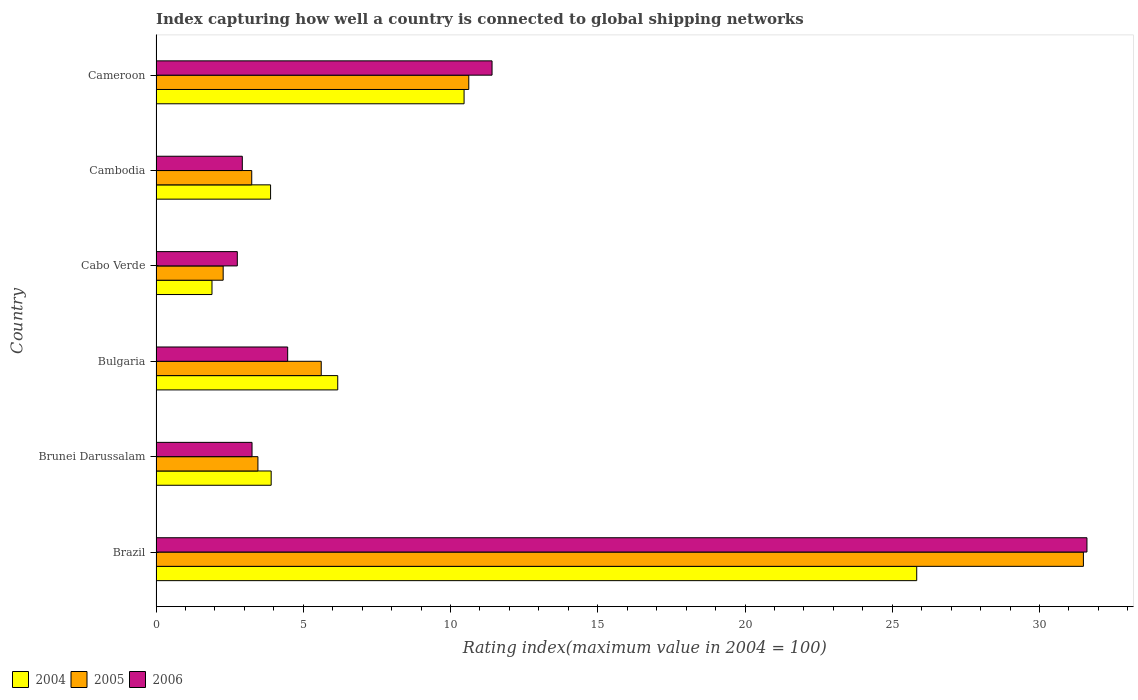How many different coloured bars are there?
Your answer should be compact. 3. How many groups of bars are there?
Your answer should be compact. 6. Are the number of bars per tick equal to the number of legend labels?
Your answer should be compact. Yes. Are the number of bars on each tick of the Y-axis equal?
Ensure brevity in your answer.  Yes. How many bars are there on the 3rd tick from the top?
Your answer should be compact. 3. What is the label of the 4th group of bars from the top?
Give a very brief answer. Bulgaria. What is the rating index in 2005 in Brazil?
Ensure brevity in your answer.  31.49. Across all countries, what is the maximum rating index in 2006?
Your answer should be compact. 31.61. Across all countries, what is the minimum rating index in 2005?
Your answer should be very brief. 2.28. In which country was the rating index in 2006 maximum?
Offer a very short reply. Brazil. In which country was the rating index in 2006 minimum?
Make the answer very short. Cabo Verde. What is the total rating index in 2004 in the graph?
Offer a very short reply. 52.16. What is the difference between the rating index in 2005 in Brunei Darussalam and that in Cabo Verde?
Offer a very short reply. 1.18. What is the difference between the rating index in 2006 in Cambodia and the rating index in 2005 in Bulgaria?
Ensure brevity in your answer.  -2.68. What is the average rating index in 2006 per country?
Keep it short and to the point. 9.41. What is the difference between the rating index in 2005 and rating index in 2004 in Cameroon?
Your response must be concise. 0.16. What is the ratio of the rating index in 2006 in Brazil to that in Bulgaria?
Your answer should be compact. 7.07. Is the rating index in 2005 in Brunei Darussalam less than that in Cambodia?
Keep it short and to the point. No. Is the difference between the rating index in 2005 in Brazil and Bulgaria greater than the difference between the rating index in 2004 in Brazil and Bulgaria?
Offer a very short reply. Yes. What is the difference between the highest and the second highest rating index in 2006?
Offer a terse response. 20.2. What is the difference between the highest and the lowest rating index in 2004?
Provide a succinct answer. 23.93. Is the sum of the rating index in 2005 in Bulgaria and Cameroon greater than the maximum rating index in 2006 across all countries?
Ensure brevity in your answer.  No. What does the 2nd bar from the bottom in Bulgaria represents?
Offer a terse response. 2005. Is it the case that in every country, the sum of the rating index in 2006 and rating index in 2004 is greater than the rating index in 2005?
Provide a short and direct response. Yes. Are all the bars in the graph horizontal?
Keep it short and to the point. Yes. Does the graph contain any zero values?
Offer a terse response. No. Does the graph contain grids?
Offer a terse response. No. Where does the legend appear in the graph?
Ensure brevity in your answer.  Bottom left. How many legend labels are there?
Make the answer very short. 3. How are the legend labels stacked?
Offer a terse response. Horizontal. What is the title of the graph?
Keep it short and to the point. Index capturing how well a country is connected to global shipping networks. What is the label or title of the X-axis?
Keep it short and to the point. Rating index(maximum value in 2004 = 100). What is the label or title of the Y-axis?
Keep it short and to the point. Country. What is the Rating index(maximum value in 2004 = 100) in 2004 in Brazil?
Your answer should be very brief. 25.83. What is the Rating index(maximum value in 2004 = 100) of 2005 in Brazil?
Provide a short and direct response. 31.49. What is the Rating index(maximum value in 2004 = 100) of 2006 in Brazil?
Make the answer very short. 31.61. What is the Rating index(maximum value in 2004 = 100) in 2004 in Brunei Darussalam?
Give a very brief answer. 3.91. What is the Rating index(maximum value in 2004 = 100) of 2005 in Brunei Darussalam?
Keep it short and to the point. 3.46. What is the Rating index(maximum value in 2004 = 100) of 2006 in Brunei Darussalam?
Your answer should be very brief. 3.26. What is the Rating index(maximum value in 2004 = 100) in 2004 in Bulgaria?
Your answer should be very brief. 6.17. What is the Rating index(maximum value in 2004 = 100) of 2005 in Bulgaria?
Ensure brevity in your answer.  5.61. What is the Rating index(maximum value in 2004 = 100) in 2006 in Bulgaria?
Your answer should be compact. 4.47. What is the Rating index(maximum value in 2004 = 100) in 2005 in Cabo Verde?
Provide a succinct answer. 2.28. What is the Rating index(maximum value in 2004 = 100) in 2006 in Cabo Verde?
Your answer should be compact. 2.76. What is the Rating index(maximum value in 2004 = 100) in 2004 in Cambodia?
Ensure brevity in your answer.  3.89. What is the Rating index(maximum value in 2004 = 100) in 2006 in Cambodia?
Keep it short and to the point. 2.93. What is the Rating index(maximum value in 2004 = 100) in 2004 in Cameroon?
Provide a short and direct response. 10.46. What is the Rating index(maximum value in 2004 = 100) in 2005 in Cameroon?
Make the answer very short. 10.62. What is the Rating index(maximum value in 2004 = 100) of 2006 in Cameroon?
Offer a terse response. 11.41. Across all countries, what is the maximum Rating index(maximum value in 2004 = 100) in 2004?
Keep it short and to the point. 25.83. Across all countries, what is the maximum Rating index(maximum value in 2004 = 100) of 2005?
Make the answer very short. 31.49. Across all countries, what is the maximum Rating index(maximum value in 2004 = 100) of 2006?
Give a very brief answer. 31.61. Across all countries, what is the minimum Rating index(maximum value in 2004 = 100) in 2005?
Provide a short and direct response. 2.28. Across all countries, what is the minimum Rating index(maximum value in 2004 = 100) of 2006?
Keep it short and to the point. 2.76. What is the total Rating index(maximum value in 2004 = 100) in 2004 in the graph?
Offer a very short reply. 52.16. What is the total Rating index(maximum value in 2004 = 100) of 2005 in the graph?
Ensure brevity in your answer.  56.71. What is the total Rating index(maximum value in 2004 = 100) of 2006 in the graph?
Your answer should be very brief. 56.44. What is the difference between the Rating index(maximum value in 2004 = 100) in 2004 in Brazil and that in Brunei Darussalam?
Your answer should be compact. 21.92. What is the difference between the Rating index(maximum value in 2004 = 100) of 2005 in Brazil and that in Brunei Darussalam?
Provide a short and direct response. 28.03. What is the difference between the Rating index(maximum value in 2004 = 100) in 2006 in Brazil and that in Brunei Darussalam?
Keep it short and to the point. 28.35. What is the difference between the Rating index(maximum value in 2004 = 100) of 2004 in Brazil and that in Bulgaria?
Offer a terse response. 19.66. What is the difference between the Rating index(maximum value in 2004 = 100) of 2005 in Brazil and that in Bulgaria?
Provide a short and direct response. 25.88. What is the difference between the Rating index(maximum value in 2004 = 100) in 2006 in Brazil and that in Bulgaria?
Offer a very short reply. 27.14. What is the difference between the Rating index(maximum value in 2004 = 100) in 2004 in Brazil and that in Cabo Verde?
Your response must be concise. 23.93. What is the difference between the Rating index(maximum value in 2004 = 100) in 2005 in Brazil and that in Cabo Verde?
Offer a terse response. 29.21. What is the difference between the Rating index(maximum value in 2004 = 100) of 2006 in Brazil and that in Cabo Verde?
Your answer should be very brief. 28.85. What is the difference between the Rating index(maximum value in 2004 = 100) of 2004 in Brazil and that in Cambodia?
Your response must be concise. 21.94. What is the difference between the Rating index(maximum value in 2004 = 100) of 2005 in Brazil and that in Cambodia?
Your answer should be compact. 28.24. What is the difference between the Rating index(maximum value in 2004 = 100) in 2006 in Brazil and that in Cambodia?
Your answer should be very brief. 28.68. What is the difference between the Rating index(maximum value in 2004 = 100) in 2004 in Brazil and that in Cameroon?
Your answer should be compact. 15.37. What is the difference between the Rating index(maximum value in 2004 = 100) of 2005 in Brazil and that in Cameroon?
Ensure brevity in your answer.  20.87. What is the difference between the Rating index(maximum value in 2004 = 100) in 2006 in Brazil and that in Cameroon?
Your answer should be very brief. 20.2. What is the difference between the Rating index(maximum value in 2004 = 100) of 2004 in Brunei Darussalam and that in Bulgaria?
Your response must be concise. -2.26. What is the difference between the Rating index(maximum value in 2004 = 100) in 2005 in Brunei Darussalam and that in Bulgaria?
Your response must be concise. -2.15. What is the difference between the Rating index(maximum value in 2004 = 100) of 2006 in Brunei Darussalam and that in Bulgaria?
Provide a succinct answer. -1.21. What is the difference between the Rating index(maximum value in 2004 = 100) in 2004 in Brunei Darussalam and that in Cabo Verde?
Your answer should be very brief. 2.01. What is the difference between the Rating index(maximum value in 2004 = 100) of 2005 in Brunei Darussalam and that in Cabo Verde?
Offer a terse response. 1.18. What is the difference between the Rating index(maximum value in 2004 = 100) in 2004 in Brunei Darussalam and that in Cambodia?
Give a very brief answer. 0.02. What is the difference between the Rating index(maximum value in 2004 = 100) in 2005 in Brunei Darussalam and that in Cambodia?
Keep it short and to the point. 0.21. What is the difference between the Rating index(maximum value in 2004 = 100) of 2006 in Brunei Darussalam and that in Cambodia?
Your answer should be very brief. 0.33. What is the difference between the Rating index(maximum value in 2004 = 100) of 2004 in Brunei Darussalam and that in Cameroon?
Your response must be concise. -6.55. What is the difference between the Rating index(maximum value in 2004 = 100) of 2005 in Brunei Darussalam and that in Cameroon?
Keep it short and to the point. -7.16. What is the difference between the Rating index(maximum value in 2004 = 100) of 2006 in Brunei Darussalam and that in Cameroon?
Your response must be concise. -8.15. What is the difference between the Rating index(maximum value in 2004 = 100) of 2004 in Bulgaria and that in Cabo Verde?
Your answer should be very brief. 4.27. What is the difference between the Rating index(maximum value in 2004 = 100) of 2005 in Bulgaria and that in Cabo Verde?
Your response must be concise. 3.33. What is the difference between the Rating index(maximum value in 2004 = 100) in 2006 in Bulgaria and that in Cabo Verde?
Ensure brevity in your answer.  1.71. What is the difference between the Rating index(maximum value in 2004 = 100) of 2004 in Bulgaria and that in Cambodia?
Provide a short and direct response. 2.28. What is the difference between the Rating index(maximum value in 2004 = 100) of 2005 in Bulgaria and that in Cambodia?
Provide a succinct answer. 2.36. What is the difference between the Rating index(maximum value in 2004 = 100) in 2006 in Bulgaria and that in Cambodia?
Your answer should be very brief. 1.54. What is the difference between the Rating index(maximum value in 2004 = 100) of 2004 in Bulgaria and that in Cameroon?
Ensure brevity in your answer.  -4.29. What is the difference between the Rating index(maximum value in 2004 = 100) of 2005 in Bulgaria and that in Cameroon?
Keep it short and to the point. -5.01. What is the difference between the Rating index(maximum value in 2004 = 100) of 2006 in Bulgaria and that in Cameroon?
Give a very brief answer. -6.94. What is the difference between the Rating index(maximum value in 2004 = 100) of 2004 in Cabo Verde and that in Cambodia?
Provide a short and direct response. -1.99. What is the difference between the Rating index(maximum value in 2004 = 100) of 2005 in Cabo Verde and that in Cambodia?
Offer a very short reply. -0.97. What is the difference between the Rating index(maximum value in 2004 = 100) of 2006 in Cabo Verde and that in Cambodia?
Your response must be concise. -0.17. What is the difference between the Rating index(maximum value in 2004 = 100) in 2004 in Cabo Verde and that in Cameroon?
Give a very brief answer. -8.56. What is the difference between the Rating index(maximum value in 2004 = 100) in 2005 in Cabo Verde and that in Cameroon?
Offer a very short reply. -8.34. What is the difference between the Rating index(maximum value in 2004 = 100) in 2006 in Cabo Verde and that in Cameroon?
Your answer should be compact. -8.65. What is the difference between the Rating index(maximum value in 2004 = 100) in 2004 in Cambodia and that in Cameroon?
Offer a very short reply. -6.57. What is the difference between the Rating index(maximum value in 2004 = 100) of 2005 in Cambodia and that in Cameroon?
Offer a very short reply. -7.37. What is the difference between the Rating index(maximum value in 2004 = 100) of 2006 in Cambodia and that in Cameroon?
Provide a short and direct response. -8.48. What is the difference between the Rating index(maximum value in 2004 = 100) in 2004 in Brazil and the Rating index(maximum value in 2004 = 100) in 2005 in Brunei Darussalam?
Offer a terse response. 22.37. What is the difference between the Rating index(maximum value in 2004 = 100) in 2004 in Brazil and the Rating index(maximum value in 2004 = 100) in 2006 in Brunei Darussalam?
Provide a succinct answer. 22.57. What is the difference between the Rating index(maximum value in 2004 = 100) in 2005 in Brazil and the Rating index(maximum value in 2004 = 100) in 2006 in Brunei Darussalam?
Make the answer very short. 28.23. What is the difference between the Rating index(maximum value in 2004 = 100) in 2004 in Brazil and the Rating index(maximum value in 2004 = 100) in 2005 in Bulgaria?
Your answer should be compact. 20.22. What is the difference between the Rating index(maximum value in 2004 = 100) of 2004 in Brazil and the Rating index(maximum value in 2004 = 100) of 2006 in Bulgaria?
Offer a terse response. 21.36. What is the difference between the Rating index(maximum value in 2004 = 100) of 2005 in Brazil and the Rating index(maximum value in 2004 = 100) of 2006 in Bulgaria?
Offer a terse response. 27.02. What is the difference between the Rating index(maximum value in 2004 = 100) in 2004 in Brazil and the Rating index(maximum value in 2004 = 100) in 2005 in Cabo Verde?
Give a very brief answer. 23.55. What is the difference between the Rating index(maximum value in 2004 = 100) of 2004 in Brazil and the Rating index(maximum value in 2004 = 100) of 2006 in Cabo Verde?
Offer a terse response. 23.07. What is the difference between the Rating index(maximum value in 2004 = 100) of 2005 in Brazil and the Rating index(maximum value in 2004 = 100) of 2006 in Cabo Verde?
Your answer should be compact. 28.73. What is the difference between the Rating index(maximum value in 2004 = 100) in 2004 in Brazil and the Rating index(maximum value in 2004 = 100) in 2005 in Cambodia?
Keep it short and to the point. 22.58. What is the difference between the Rating index(maximum value in 2004 = 100) of 2004 in Brazil and the Rating index(maximum value in 2004 = 100) of 2006 in Cambodia?
Make the answer very short. 22.9. What is the difference between the Rating index(maximum value in 2004 = 100) in 2005 in Brazil and the Rating index(maximum value in 2004 = 100) in 2006 in Cambodia?
Provide a succinct answer. 28.56. What is the difference between the Rating index(maximum value in 2004 = 100) of 2004 in Brazil and the Rating index(maximum value in 2004 = 100) of 2005 in Cameroon?
Ensure brevity in your answer.  15.21. What is the difference between the Rating index(maximum value in 2004 = 100) in 2004 in Brazil and the Rating index(maximum value in 2004 = 100) in 2006 in Cameroon?
Provide a succinct answer. 14.42. What is the difference between the Rating index(maximum value in 2004 = 100) of 2005 in Brazil and the Rating index(maximum value in 2004 = 100) of 2006 in Cameroon?
Give a very brief answer. 20.08. What is the difference between the Rating index(maximum value in 2004 = 100) of 2004 in Brunei Darussalam and the Rating index(maximum value in 2004 = 100) of 2006 in Bulgaria?
Your answer should be very brief. -0.56. What is the difference between the Rating index(maximum value in 2004 = 100) in 2005 in Brunei Darussalam and the Rating index(maximum value in 2004 = 100) in 2006 in Bulgaria?
Offer a very short reply. -1.01. What is the difference between the Rating index(maximum value in 2004 = 100) of 2004 in Brunei Darussalam and the Rating index(maximum value in 2004 = 100) of 2005 in Cabo Verde?
Your response must be concise. 1.63. What is the difference between the Rating index(maximum value in 2004 = 100) in 2004 in Brunei Darussalam and the Rating index(maximum value in 2004 = 100) in 2006 in Cabo Verde?
Your answer should be compact. 1.15. What is the difference between the Rating index(maximum value in 2004 = 100) in 2004 in Brunei Darussalam and the Rating index(maximum value in 2004 = 100) in 2005 in Cambodia?
Ensure brevity in your answer.  0.66. What is the difference between the Rating index(maximum value in 2004 = 100) in 2005 in Brunei Darussalam and the Rating index(maximum value in 2004 = 100) in 2006 in Cambodia?
Provide a short and direct response. 0.53. What is the difference between the Rating index(maximum value in 2004 = 100) in 2004 in Brunei Darussalam and the Rating index(maximum value in 2004 = 100) in 2005 in Cameroon?
Provide a short and direct response. -6.71. What is the difference between the Rating index(maximum value in 2004 = 100) in 2005 in Brunei Darussalam and the Rating index(maximum value in 2004 = 100) in 2006 in Cameroon?
Ensure brevity in your answer.  -7.95. What is the difference between the Rating index(maximum value in 2004 = 100) in 2004 in Bulgaria and the Rating index(maximum value in 2004 = 100) in 2005 in Cabo Verde?
Your answer should be very brief. 3.89. What is the difference between the Rating index(maximum value in 2004 = 100) of 2004 in Bulgaria and the Rating index(maximum value in 2004 = 100) of 2006 in Cabo Verde?
Your response must be concise. 3.41. What is the difference between the Rating index(maximum value in 2004 = 100) of 2005 in Bulgaria and the Rating index(maximum value in 2004 = 100) of 2006 in Cabo Verde?
Your answer should be very brief. 2.85. What is the difference between the Rating index(maximum value in 2004 = 100) of 2004 in Bulgaria and the Rating index(maximum value in 2004 = 100) of 2005 in Cambodia?
Offer a terse response. 2.92. What is the difference between the Rating index(maximum value in 2004 = 100) in 2004 in Bulgaria and the Rating index(maximum value in 2004 = 100) in 2006 in Cambodia?
Make the answer very short. 3.24. What is the difference between the Rating index(maximum value in 2004 = 100) in 2005 in Bulgaria and the Rating index(maximum value in 2004 = 100) in 2006 in Cambodia?
Your response must be concise. 2.68. What is the difference between the Rating index(maximum value in 2004 = 100) in 2004 in Bulgaria and the Rating index(maximum value in 2004 = 100) in 2005 in Cameroon?
Your answer should be compact. -4.45. What is the difference between the Rating index(maximum value in 2004 = 100) of 2004 in Bulgaria and the Rating index(maximum value in 2004 = 100) of 2006 in Cameroon?
Your response must be concise. -5.24. What is the difference between the Rating index(maximum value in 2004 = 100) of 2004 in Cabo Verde and the Rating index(maximum value in 2004 = 100) of 2005 in Cambodia?
Your response must be concise. -1.35. What is the difference between the Rating index(maximum value in 2004 = 100) of 2004 in Cabo Verde and the Rating index(maximum value in 2004 = 100) of 2006 in Cambodia?
Make the answer very short. -1.03. What is the difference between the Rating index(maximum value in 2004 = 100) of 2005 in Cabo Verde and the Rating index(maximum value in 2004 = 100) of 2006 in Cambodia?
Provide a short and direct response. -0.65. What is the difference between the Rating index(maximum value in 2004 = 100) of 2004 in Cabo Verde and the Rating index(maximum value in 2004 = 100) of 2005 in Cameroon?
Offer a terse response. -8.72. What is the difference between the Rating index(maximum value in 2004 = 100) of 2004 in Cabo Verde and the Rating index(maximum value in 2004 = 100) of 2006 in Cameroon?
Make the answer very short. -9.51. What is the difference between the Rating index(maximum value in 2004 = 100) in 2005 in Cabo Verde and the Rating index(maximum value in 2004 = 100) in 2006 in Cameroon?
Your answer should be compact. -9.13. What is the difference between the Rating index(maximum value in 2004 = 100) in 2004 in Cambodia and the Rating index(maximum value in 2004 = 100) in 2005 in Cameroon?
Give a very brief answer. -6.73. What is the difference between the Rating index(maximum value in 2004 = 100) of 2004 in Cambodia and the Rating index(maximum value in 2004 = 100) of 2006 in Cameroon?
Provide a short and direct response. -7.52. What is the difference between the Rating index(maximum value in 2004 = 100) of 2005 in Cambodia and the Rating index(maximum value in 2004 = 100) of 2006 in Cameroon?
Offer a very short reply. -8.16. What is the average Rating index(maximum value in 2004 = 100) of 2004 per country?
Keep it short and to the point. 8.69. What is the average Rating index(maximum value in 2004 = 100) of 2005 per country?
Your answer should be compact. 9.45. What is the average Rating index(maximum value in 2004 = 100) in 2006 per country?
Make the answer very short. 9.41. What is the difference between the Rating index(maximum value in 2004 = 100) of 2004 and Rating index(maximum value in 2004 = 100) of 2005 in Brazil?
Your response must be concise. -5.66. What is the difference between the Rating index(maximum value in 2004 = 100) in 2004 and Rating index(maximum value in 2004 = 100) in 2006 in Brazil?
Give a very brief answer. -5.78. What is the difference between the Rating index(maximum value in 2004 = 100) of 2005 and Rating index(maximum value in 2004 = 100) of 2006 in Brazil?
Your answer should be very brief. -0.12. What is the difference between the Rating index(maximum value in 2004 = 100) of 2004 and Rating index(maximum value in 2004 = 100) of 2005 in Brunei Darussalam?
Your answer should be very brief. 0.45. What is the difference between the Rating index(maximum value in 2004 = 100) of 2004 and Rating index(maximum value in 2004 = 100) of 2006 in Brunei Darussalam?
Provide a short and direct response. 0.65. What is the difference between the Rating index(maximum value in 2004 = 100) in 2004 and Rating index(maximum value in 2004 = 100) in 2005 in Bulgaria?
Provide a succinct answer. 0.56. What is the difference between the Rating index(maximum value in 2004 = 100) of 2004 and Rating index(maximum value in 2004 = 100) of 2006 in Bulgaria?
Offer a terse response. 1.7. What is the difference between the Rating index(maximum value in 2004 = 100) in 2005 and Rating index(maximum value in 2004 = 100) in 2006 in Bulgaria?
Ensure brevity in your answer.  1.14. What is the difference between the Rating index(maximum value in 2004 = 100) of 2004 and Rating index(maximum value in 2004 = 100) of 2005 in Cabo Verde?
Keep it short and to the point. -0.38. What is the difference between the Rating index(maximum value in 2004 = 100) of 2004 and Rating index(maximum value in 2004 = 100) of 2006 in Cabo Verde?
Provide a short and direct response. -0.86. What is the difference between the Rating index(maximum value in 2004 = 100) in 2005 and Rating index(maximum value in 2004 = 100) in 2006 in Cabo Verde?
Ensure brevity in your answer.  -0.48. What is the difference between the Rating index(maximum value in 2004 = 100) in 2004 and Rating index(maximum value in 2004 = 100) in 2005 in Cambodia?
Give a very brief answer. 0.64. What is the difference between the Rating index(maximum value in 2004 = 100) in 2005 and Rating index(maximum value in 2004 = 100) in 2006 in Cambodia?
Offer a terse response. 0.32. What is the difference between the Rating index(maximum value in 2004 = 100) in 2004 and Rating index(maximum value in 2004 = 100) in 2005 in Cameroon?
Ensure brevity in your answer.  -0.16. What is the difference between the Rating index(maximum value in 2004 = 100) of 2004 and Rating index(maximum value in 2004 = 100) of 2006 in Cameroon?
Your response must be concise. -0.95. What is the difference between the Rating index(maximum value in 2004 = 100) of 2005 and Rating index(maximum value in 2004 = 100) of 2006 in Cameroon?
Provide a short and direct response. -0.79. What is the ratio of the Rating index(maximum value in 2004 = 100) in 2004 in Brazil to that in Brunei Darussalam?
Your answer should be very brief. 6.61. What is the ratio of the Rating index(maximum value in 2004 = 100) of 2005 in Brazil to that in Brunei Darussalam?
Provide a short and direct response. 9.1. What is the ratio of the Rating index(maximum value in 2004 = 100) in 2006 in Brazil to that in Brunei Darussalam?
Your response must be concise. 9.7. What is the ratio of the Rating index(maximum value in 2004 = 100) of 2004 in Brazil to that in Bulgaria?
Your answer should be compact. 4.19. What is the ratio of the Rating index(maximum value in 2004 = 100) in 2005 in Brazil to that in Bulgaria?
Offer a very short reply. 5.61. What is the ratio of the Rating index(maximum value in 2004 = 100) of 2006 in Brazil to that in Bulgaria?
Ensure brevity in your answer.  7.07. What is the ratio of the Rating index(maximum value in 2004 = 100) of 2004 in Brazil to that in Cabo Verde?
Provide a short and direct response. 13.59. What is the ratio of the Rating index(maximum value in 2004 = 100) of 2005 in Brazil to that in Cabo Verde?
Give a very brief answer. 13.81. What is the ratio of the Rating index(maximum value in 2004 = 100) in 2006 in Brazil to that in Cabo Verde?
Your response must be concise. 11.45. What is the ratio of the Rating index(maximum value in 2004 = 100) in 2004 in Brazil to that in Cambodia?
Provide a succinct answer. 6.64. What is the ratio of the Rating index(maximum value in 2004 = 100) of 2005 in Brazil to that in Cambodia?
Give a very brief answer. 9.69. What is the ratio of the Rating index(maximum value in 2004 = 100) in 2006 in Brazil to that in Cambodia?
Offer a terse response. 10.79. What is the ratio of the Rating index(maximum value in 2004 = 100) of 2004 in Brazil to that in Cameroon?
Your answer should be very brief. 2.47. What is the ratio of the Rating index(maximum value in 2004 = 100) in 2005 in Brazil to that in Cameroon?
Provide a succinct answer. 2.97. What is the ratio of the Rating index(maximum value in 2004 = 100) in 2006 in Brazil to that in Cameroon?
Make the answer very short. 2.77. What is the ratio of the Rating index(maximum value in 2004 = 100) of 2004 in Brunei Darussalam to that in Bulgaria?
Offer a terse response. 0.63. What is the ratio of the Rating index(maximum value in 2004 = 100) in 2005 in Brunei Darussalam to that in Bulgaria?
Your answer should be very brief. 0.62. What is the ratio of the Rating index(maximum value in 2004 = 100) in 2006 in Brunei Darussalam to that in Bulgaria?
Offer a very short reply. 0.73. What is the ratio of the Rating index(maximum value in 2004 = 100) of 2004 in Brunei Darussalam to that in Cabo Verde?
Your response must be concise. 2.06. What is the ratio of the Rating index(maximum value in 2004 = 100) of 2005 in Brunei Darussalam to that in Cabo Verde?
Offer a very short reply. 1.52. What is the ratio of the Rating index(maximum value in 2004 = 100) of 2006 in Brunei Darussalam to that in Cabo Verde?
Offer a terse response. 1.18. What is the ratio of the Rating index(maximum value in 2004 = 100) in 2004 in Brunei Darussalam to that in Cambodia?
Offer a terse response. 1.01. What is the ratio of the Rating index(maximum value in 2004 = 100) in 2005 in Brunei Darussalam to that in Cambodia?
Provide a short and direct response. 1.06. What is the ratio of the Rating index(maximum value in 2004 = 100) in 2006 in Brunei Darussalam to that in Cambodia?
Give a very brief answer. 1.11. What is the ratio of the Rating index(maximum value in 2004 = 100) of 2004 in Brunei Darussalam to that in Cameroon?
Provide a succinct answer. 0.37. What is the ratio of the Rating index(maximum value in 2004 = 100) of 2005 in Brunei Darussalam to that in Cameroon?
Provide a short and direct response. 0.33. What is the ratio of the Rating index(maximum value in 2004 = 100) of 2006 in Brunei Darussalam to that in Cameroon?
Make the answer very short. 0.29. What is the ratio of the Rating index(maximum value in 2004 = 100) of 2004 in Bulgaria to that in Cabo Verde?
Your answer should be compact. 3.25. What is the ratio of the Rating index(maximum value in 2004 = 100) in 2005 in Bulgaria to that in Cabo Verde?
Your answer should be very brief. 2.46. What is the ratio of the Rating index(maximum value in 2004 = 100) of 2006 in Bulgaria to that in Cabo Verde?
Keep it short and to the point. 1.62. What is the ratio of the Rating index(maximum value in 2004 = 100) of 2004 in Bulgaria to that in Cambodia?
Offer a very short reply. 1.59. What is the ratio of the Rating index(maximum value in 2004 = 100) in 2005 in Bulgaria to that in Cambodia?
Offer a very short reply. 1.73. What is the ratio of the Rating index(maximum value in 2004 = 100) of 2006 in Bulgaria to that in Cambodia?
Your response must be concise. 1.53. What is the ratio of the Rating index(maximum value in 2004 = 100) of 2004 in Bulgaria to that in Cameroon?
Offer a terse response. 0.59. What is the ratio of the Rating index(maximum value in 2004 = 100) of 2005 in Bulgaria to that in Cameroon?
Your answer should be compact. 0.53. What is the ratio of the Rating index(maximum value in 2004 = 100) in 2006 in Bulgaria to that in Cameroon?
Offer a terse response. 0.39. What is the ratio of the Rating index(maximum value in 2004 = 100) in 2004 in Cabo Verde to that in Cambodia?
Provide a short and direct response. 0.49. What is the ratio of the Rating index(maximum value in 2004 = 100) of 2005 in Cabo Verde to that in Cambodia?
Ensure brevity in your answer.  0.7. What is the ratio of the Rating index(maximum value in 2004 = 100) in 2006 in Cabo Verde to that in Cambodia?
Ensure brevity in your answer.  0.94. What is the ratio of the Rating index(maximum value in 2004 = 100) in 2004 in Cabo Verde to that in Cameroon?
Make the answer very short. 0.18. What is the ratio of the Rating index(maximum value in 2004 = 100) in 2005 in Cabo Verde to that in Cameroon?
Your response must be concise. 0.21. What is the ratio of the Rating index(maximum value in 2004 = 100) of 2006 in Cabo Verde to that in Cameroon?
Offer a very short reply. 0.24. What is the ratio of the Rating index(maximum value in 2004 = 100) in 2004 in Cambodia to that in Cameroon?
Ensure brevity in your answer.  0.37. What is the ratio of the Rating index(maximum value in 2004 = 100) in 2005 in Cambodia to that in Cameroon?
Ensure brevity in your answer.  0.31. What is the ratio of the Rating index(maximum value in 2004 = 100) in 2006 in Cambodia to that in Cameroon?
Ensure brevity in your answer.  0.26. What is the difference between the highest and the second highest Rating index(maximum value in 2004 = 100) of 2004?
Your answer should be compact. 15.37. What is the difference between the highest and the second highest Rating index(maximum value in 2004 = 100) in 2005?
Ensure brevity in your answer.  20.87. What is the difference between the highest and the second highest Rating index(maximum value in 2004 = 100) in 2006?
Keep it short and to the point. 20.2. What is the difference between the highest and the lowest Rating index(maximum value in 2004 = 100) in 2004?
Keep it short and to the point. 23.93. What is the difference between the highest and the lowest Rating index(maximum value in 2004 = 100) of 2005?
Offer a terse response. 29.21. What is the difference between the highest and the lowest Rating index(maximum value in 2004 = 100) in 2006?
Keep it short and to the point. 28.85. 